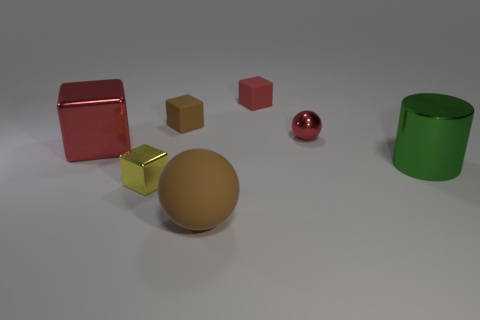Subtract all tiny blocks. How many blocks are left? 1 Subtract all brown balls. How many balls are left? 1 Add 1 tiny green blocks. How many objects exist? 8 Subtract all balls. How many objects are left? 5 Subtract all purple balls. How many red blocks are left? 2 Subtract all metal things. Subtract all tiny red balls. How many objects are left? 2 Add 1 big green shiny cylinders. How many big green shiny cylinders are left? 2 Add 4 large red metallic things. How many large red metallic things exist? 5 Subtract 1 yellow cubes. How many objects are left? 6 Subtract 2 spheres. How many spheres are left? 0 